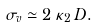<formula> <loc_0><loc_0><loc_500><loc_500>\ \sigma _ { v } \simeq 2 \, \kappa _ { 2 } \, { D } .</formula> 